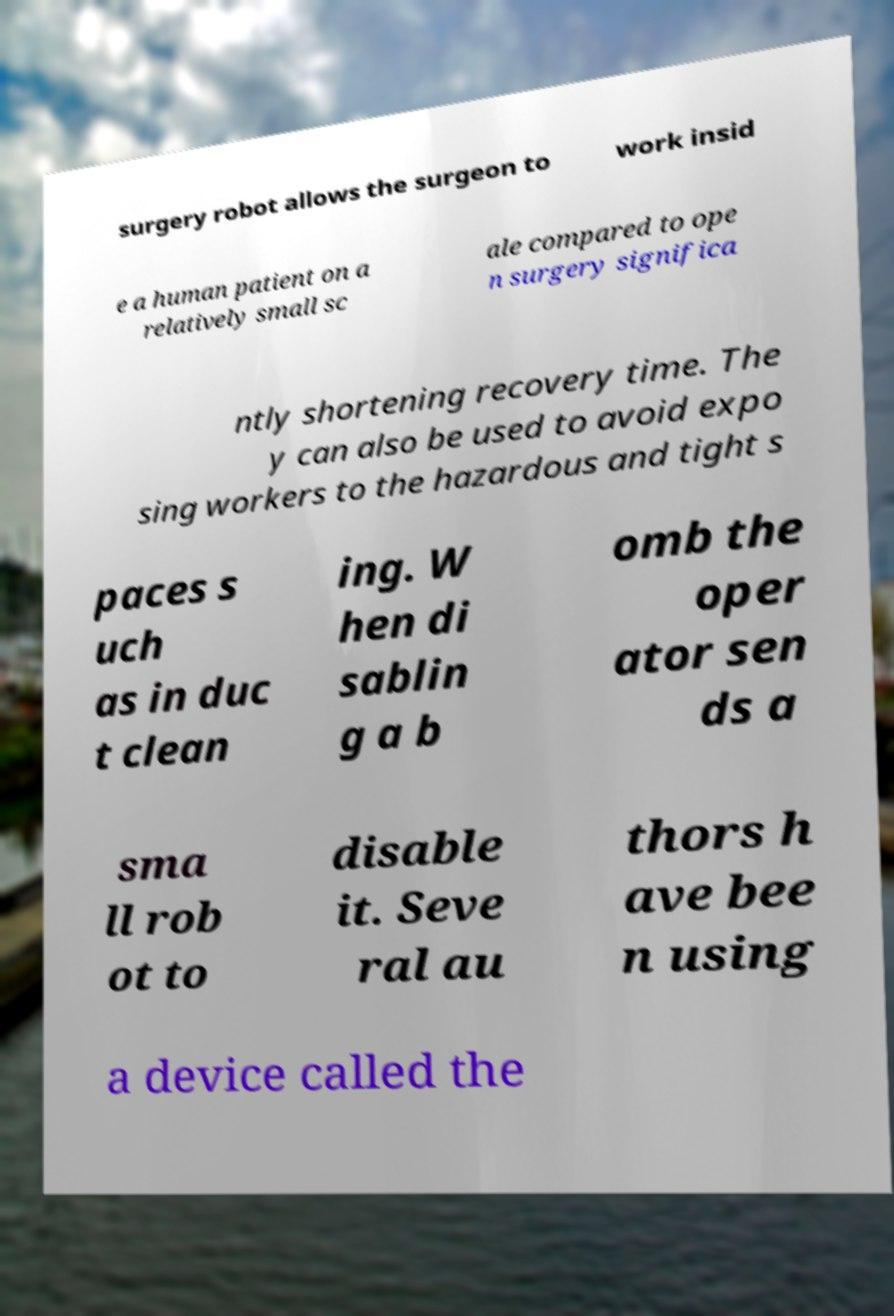Please identify and transcribe the text found in this image. surgery robot allows the surgeon to work insid e a human patient on a relatively small sc ale compared to ope n surgery significa ntly shortening recovery time. The y can also be used to avoid expo sing workers to the hazardous and tight s paces s uch as in duc t clean ing. W hen di sablin g a b omb the oper ator sen ds a sma ll rob ot to disable it. Seve ral au thors h ave bee n using a device called the 